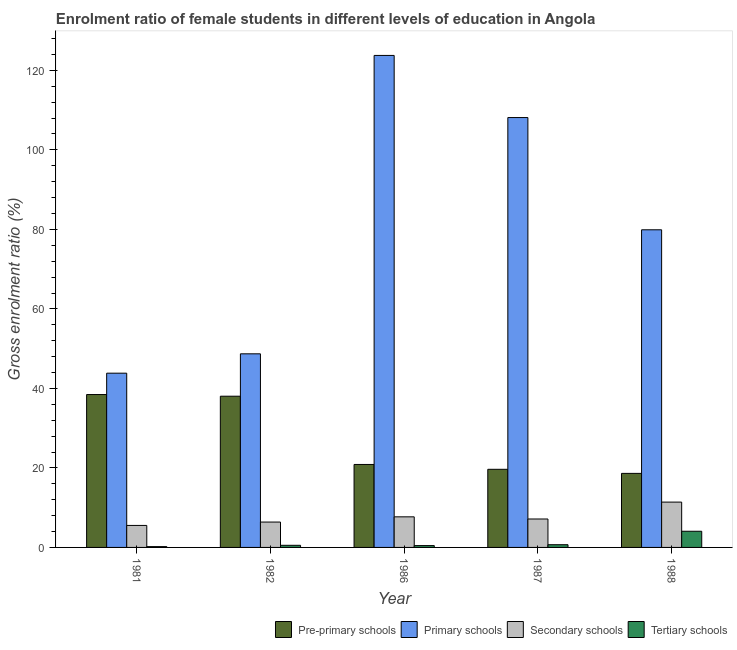How many groups of bars are there?
Ensure brevity in your answer.  5. Are the number of bars per tick equal to the number of legend labels?
Your answer should be compact. Yes. How many bars are there on the 3rd tick from the left?
Your answer should be very brief. 4. What is the label of the 2nd group of bars from the left?
Give a very brief answer. 1982. In how many cases, is the number of bars for a given year not equal to the number of legend labels?
Make the answer very short. 0. What is the gross enrolment ratio(male) in pre-primary schools in 1986?
Your answer should be compact. 20.87. Across all years, what is the maximum gross enrolment ratio(male) in tertiary schools?
Provide a short and direct response. 4.07. Across all years, what is the minimum gross enrolment ratio(male) in pre-primary schools?
Make the answer very short. 18.63. In which year was the gross enrolment ratio(male) in secondary schools maximum?
Your response must be concise. 1988. In which year was the gross enrolment ratio(male) in primary schools minimum?
Provide a succinct answer. 1981. What is the total gross enrolment ratio(male) in tertiary schools in the graph?
Your answer should be compact. 5.95. What is the difference between the gross enrolment ratio(male) in tertiary schools in 1982 and that in 1987?
Ensure brevity in your answer.  -0.15. What is the difference between the gross enrolment ratio(male) in tertiary schools in 1982 and the gross enrolment ratio(male) in pre-primary schools in 1986?
Make the answer very short. 0.07. What is the average gross enrolment ratio(male) in secondary schools per year?
Make the answer very short. 7.63. What is the ratio of the gross enrolment ratio(male) in pre-primary schools in 1982 to that in 1988?
Your answer should be compact. 2.04. What is the difference between the highest and the second highest gross enrolment ratio(male) in pre-primary schools?
Your answer should be very brief. 0.42. What is the difference between the highest and the lowest gross enrolment ratio(male) in tertiary schools?
Make the answer very short. 3.87. In how many years, is the gross enrolment ratio(male) in secondary schools greater than the average gross enrolment ratio(male) in secondary schools taken over all years?
Ensure brevity in your answer.  2. Is the sum of the gross enrolment ratio(male) in primary schools in 1987 and 1988 greater than the maximum gross enrolment ratio(male) in pre-primary schools across all years?
Keep it short and to the point. Yes. What does the 2nd bar from the left in 1981 represents?
Ensure brevity in your answer.  Primary schools. What does the 2nd bar from the right in 1988 represents?
Provide a short and direct response. Secondary schools. Are all the bars in the graph horizontal?
Provide a short and direct response. No. How many years are there in the graph?
Your answer should be very brief. 5. Are the values on the major ticks of Y-axis written in scientific E-notation?
Offer a very short reply. No. Does the graph contain any zero values?
Give a very brief answer. No. Does the graph contain grids?
Offer a terse response. No. Where does the legend appear in the graph?
Provide a succinct answer. Bottom right. How are the legend labels stacked?
Offer a very short reply. Horizontal. What is the title of the graph?
Ensure brevity in your answer.  Enrolment ratio of female students in different levels of education in Angola. Does "Second 20% of population" appear as one of the legend labels in the graph?
Make the answer very short. No. What is the label or title of the X-axis?
Make the answer very short. Year. What is the label or title of the Y-axis?
Your response must be concise. Gross enrolment ratio (%). What is the Gross enrolment ratio (%) of Pre-primary schools in 1981?
Give a very brief answer. 38.46. What is the Gross enrolment ratio (%) of Primary schools in 1981?
Offer a very short reply. 43.83. What is the Gross enrolment ratio (%) in Secondary schools in 1981?
Offer a terse response. 5.53. What is the Gross enrolment ratio (%) in Tertiary schools in 1981?
Your answer should be compact. 0.2. What is the Gross enrolment ratio (%) of Pre-primary schools in 1982?
Offer a terse response. 38.04. What is the Gross enrolment ratio (%) of Primary schools in 1982?
Keep it short and to the point. 48.7. What is the Gross enrolment ratio (%) in Secondary schools in 1982?
Your answer should be compact. 6.38. What is the Gross enrolment ratio (%) of Tertiary schools in 1982?
Your response must be concise. 0.53. What is the Gross enrolment ratio (%) in Pre-primary schools in 1986?
Keep it short and to the point. 20.87. What is the Gross enrolment ratio (%) in Primary schools in 1986?
Provide a succinct answer. 123.76. What is the Gross enrolment ratio (%) of Secondary schools in 1986?
Your response must be concise. 7.7. What is the Gross enrolment ratio (%) of Tertiary schools in 1986?
Give a very brief answer. 0.46. What is the Gross enrolment ratio (%) in Pre-primary schools in 1987?
Offer a terse response. 19.65. What is the Gross enrolment ratio (%) in Primary schools in 1987?
Make the answer very short. 108.13. What is the Gross enrolment ratio (%) in Secondary schools in 1987?
Offer a very short reply. 7.15. What is the Gross enrolment ratio (%) of Tertiary schools in 1987?
Keep it short and to the point. 0.68. What is the Gross enrolment ratio (%) of Pre-primary schools in 1988?
Your answer should be compact. 18.63. What is the Gross enrolment ratio (%) of Primary schools in 1988?
Provide a succinct answer. 79.9. What is the Gross enrolment ratio (%) in Secondary schools in 1988?
Ensure brevity in your answer.  11.4. What is the Gross enrolment ratio (%) of Tertiary schools in 1988?
Give a very brief answer. 4.07. Across all years, what is the maximum Gross enrolment ratio (%) in Pre-primary schools?
Your answer should be very brief. 38.46. Across all years, what is the maximum Gross enrolment ratio (%) of Primary schools?
Offer a terse response. 123.76. Across all years, what is the maximum Gross enrolment ratio (%) of Secondary schools?
Ensure brevity in your answer.  11.4. Across all years, what is the maximum Gross enrolment ratio (%) of Tertiary schools?
Make the answer very short. 4.07. Across all years, what is the minimum Gross enrolment ratio (%) in Pre-primary schools?
Your answer should be very brief. 18.63. Across all years, what is the minimum Gross enrolment ratio (%) in Primary schools?
Offer a very short reply. 43.83. Across all years, what is the minimum Gross enrolment ratio (%) in Secondary schools?
Your response must be concise. 5.53. Across all years, what is the minimum Gross enrolment ratio (%) in Tertiary schools?
Your answer should be very brief. 0.2. What is the total Gross enrolment ratio (%) in Pre-primary schools in the graph?
Give a very brief answer. 135.64. What is the total Gross enrolment ratio (%) in Primary schools in the graph?
Provide a short and direct response. 404.33. What is the total Gross enrolment ratio (%) of Secondary schools in the graph?
Offer a very short reply. 38.16. What is the total Gross enrolment ratio (%) in Tertiary schools in the graph?
Provide a succinct answer. 5.95. What is the difference between the Gross enrolment ratio (%) of Pre-primary schools in 1981 and that in 1982?
Keep it short and to the point. 0.42. What is the difference between the Gross enrolment ratio (%) of Primary schools in 1981 and that in 1982?
Ensure brevity in your answer.  -4.87. What is the difference between the Gross enrolment ratio (%) in Secondary schools in 1981 and that in 1982?
Provide a short and direct response. -0.85. What is the difference between the Gross enrolment ratio (%) of Tertiary schools in 1981 and that in 1982?
Offer a terse response. -0.33. What is the difference between the Gross enrolment ratio (%) of Pre-primary schools in 1981 and that in 1986?
Offer a terse response. 17.59. What is the difference between the Gross enrolment ratio (%) of Primary schools in 1981 and that in 1986?
Your response must be concise. -79.93. What is the difference between the Gross enrolment ratio (%) in Secondary schools in 1981 and that in 1986?
Provide a succinct answer. -2.16. What is the difference between the Gross enrolment ratio (%) in Tertiary schools in 1981 and that in 1986?
Provide a short and direct response. -0.26. What is the difference between the Gross enrolment ratio (%) in Pre-primary schools in 1981 and that in 1987?
Give a very brief answer. 18.81. What is the difference between the Gross enrolment ratio (%) of Primary schools in 1981 and that in 1987?
Your answer should be very brief. -64.3. What is the difference between the Gross enrolment ratio (%) of Secondary schools in 1981 and that in 1987?
Ensure brevity in your answer.  -1.62. What is the difference between the Gross enrolment ratio (%) in Tertiary schools in 1981 and that in 1987?
Offer a very short reply. -0.48. What is the difference between the Gross enrolment ratio (%) in Pre-primary schools in 1981 and that in 1988?
Provide a short and direct response. 19.83. What is the difference between the Gross enrolment ratio (%) in Primary schools in 1981 and that in 1988?
Ensure brevity in your answer.  -36.07. What is the difference between the Gross enrolment ratio (%) of Secondary schools in 1981 and that in 1988?
Your answer should be compact. -5.87. What is the difference between the Gross enrolment ratio (%) in Tertiary schools in 1981 and that in 1988?
Your answer should be compact. -3.87. What is the difference between the Gross enrolment ratio (%) of Pre-primary schools in 1982 and that in 1986?
Offer a terse response. 17.17. What is the difference between the Gross enrolment ratio (%) of Primary schools in 1982 and that in 1986?
Provide a short and direct response. -75.06. What is the difference between the Gross enrolment ratio (%) of Secondary schools in 1982 and that in 1986?
Ensure brevity in your answer.  -1.31. What is the difference between the Gross enrolment ratio (%) in Tertiary schools in 1982 and that in 1986?
Your response must be concise. 0.07. What is the difference between the Gross enrolment ratio (%) in Pre-primary schools in 1982 and that in 1987?
Offer a terse response. 18.39. What is the difference between the Gross enrolment ratio (%) of Primary schools in 1982 and that in 1987?
Provide a succinct answer. -59.43. What is the difference between the Gross enrolment ratio (%) of Secondary schools in 1982 and that in 1987?
Offer a very short reply. -0.77. What is the difference between the Gross enrolment ratio (%) in Tertiary schools in 1982 and that in 1987?
Give a very brief answer. -0.15. What is the difference between the Gross enrolment ratio (%) in Pre-primary schools in 1982 and that in 1988?
Offer a very short reply. 19.41. What is the difference between the Gross enrolment ratio (%) of Primary schools in 1982 and that in 1988?
Ensure brevity in your answer.  -31.2. What is the difference between the Gross enrolment ratio (%) in Secondary schools in 1982 and that in 1988?
Offer a very short reply. -5.02. What is the difference between the Gross enrolment ratio (%) in Tertiary schools in 1982 and that in 1988?
Provide a short and direct response. -3.53. What is the difference between the Gross enrolment ratio (%) in Pre-primary schools in 1986 and that in 1987?
Your response must be concise. 1.22. What is the difference between the Gross enrolment ratio (%) of Primary schools in 1986 and that in 1987?
Offer a terse response. 15.63. What is the difference between the Gross enrolment ratio (%) of Secondary schools in 1986 and that in 1987?
Your answer should be very brief. 0.55. What is the difference between the Gross enrolment ratio (%) of Tertiary schools in 1986 and that in 1987?
Your response must be concise. -0.22. What is the difference between the Gross enrolment ratio (%) of Pre-primary schools in 1986 and that in 1988?
Provide a succinct answer. 2.24. What is the difference between the Gross enrolment ratio (%) of Primary schools in 1986 and that in 1988?
Your response must be concise. 43.86. What is the difference between the Gross enrolment ratio (%) of Secondary schools in 1986 and that in 1988?
Your answer should be very brief. -3.71. What is the difference between the Gross enrolment ratio (%) in Tertiary schools in 1986 and that in 1988?
Your answer should be very brief. -3.61. What is the difference between the Gross enrolment ratio (%) in Pre-primary schools in 1987 and that in 1988?
Your answer should be very brief. 1.02. What is the difference between the Gross enrolment ratio (%) in Primary schools in 1987 and that in 1988?
Give a very brief answer. 28.23. What is the difference between the Gross enrolment ratio (%) in Secondary schools in 1987 and that in 1988?
Provide a short and direct response. -4.25. What is the difference between the Gross enrolment ratio (%) of Tertiary schools in 1987 and that in 1988?
Your response must be concise. -3.38. What is the difference between the Gross enrolment ratio (%) in Pre-primary schools in 1981 and the Gross enrolment ratio (%) in Primary schools in 1982?
Provide a succinct answer. -10.24. What is the difference between the Gross enrolment ratio (%) in Pre-primary schools in 1981 and the Gross enrolment ratio (%) in Secondary schools in 1982?
Your answer should be compact. 32.08. What is the difference between the Gross enrolment ratio (%) in Pre-primary schools in 1981 and the Gross enrolment ratio (%) in Tertiary schools in 1982?
Ensure brevity in your answer.  37.92. What is the difference between the Gross enrolment ratio (%) of Primary schools in 1981 and the Gross enrolment ratio (%) of Secondary schools in 1982?
Keep it short and to the point. 37.45. What is the difference between the Gross enrolment ratio (%) of Primary schools in 1981 and the Gross enrolment ratio (%) of Tertiary schools in 1982?
Your answer should be compact. 43.3. What is the difference between the Gross enrolment ratio (%) of Secondary schools in 1981 and the Gross enrolment ratio (%) of Tertiary schools in 1982?
Provide a short and direct response. 5. What is the difference between the Gross enrolment ratio (%) of Pre-primary schools in 1981 and the Gross enrolment ratio (%) of Primary schools in 1986?
Give a very brief answer. -85.3. What is the difference between the Gross enrolment ratio (%) in Pre-primary schools in 1981 and the Gross enrolment ratio (%) in Secondary schools in 1986?
Keep it short and to the point. 30.76. What is the difference between the Gross enrolment ratio (%) in Pre-primary schools in 1981 and the Gross enrolment ratio (%) in Tertiary schools in 1986?
Your answer should be compact. 38. What is the difference between the Gross enrolment ratio (%) in Primary schools in 1981 and the Gross enrolment ratio (%) in Secondary schools in 1986?
Provide a succinct answer. 36.14. What is the difference between the Gross enrolment ratio (%) of Primary schools in 1981 and the Gross enrolment ratio (%) of Tertiary schools in 1986?
Ensure brevity in your answer.  43.37. What is the difference between the Gross enrolment ratio (%) of Secondary schools in 1981 and the Gross enrolment ratio (%) of Tertiary schools in 1986?
Your answer should be very brief. 5.07. What is the difference between the Gross enrolment ratio (%) in Pre-primary schools in 1981 and the Gross enrolment ratio (%) in Primary schools in 1987?
Give a very brief answer. -69.67. What is the difference between the Gross enrolment ratio (%) of Pre-primary schools in 1981 and the Gross enrolment ratio (%) of Secondary schools in 1987?
Offer a very short reply. 31.31. What is the difference between the Gross enrolment ratio (%) of Pre-primary schools in 1981 and the Gross enrolment ratio (%) of Tertiary schools in 1987?
Your answer should be very brief. 37.77. What is the difference between the Gross enrolment ratio (%) in Primary schools in 1981 and the Gross enrolment ratio (%) in Secondary schools in 1987?
Your response must be concise. 36.68. What is the difference between the Gross enrolment ratio (%) in Primary schools in 1981 and the Gross enrolment ratio (%) in Tertiary schools in 1987?
Ensure brevity in your answer.  43.15. What is the difference between the Gross enrolment ratio (%) in Secondary schools in 1981 and the Gross enrolment ratio (%) in Tertiary schools in 1987?
Make the answer very short. 4.85. What is the difference between the Gross enrolment ratio (%) of Pre-primary schools in 1981 and the Gross enrolment ratio (%) of Primary schools in 1988?
Your answer should be compact. -41.44. What is the difference between the Gross enrolment ratio (%) of Pre-primary schools in 1981 and the Gross enrolment ratio (%) of Secondary schools in 1988?
Give a very brief answer. 27.05. What is the difference between the Gross enrolment ratio (%) in Pre-primary schools in 1981 and the Gross enrolment ratio (%) in Tertiary schools in 1988?
Offer a very short reply. 34.39. What is the difference between the Gross enrolment ratio (%) of Primary schools in 1981 and the Gross enrolment ratio (%) of Secondary schools in 1988?
Keep it short and to the point. 32.43. What is the difference between the Gross enrolment ratio (%) in Primary schools in 1981 and the Gross enrolment ratio (%) in Tertiary schools in 1988?
Keep it short and to the point. 39.76. What is the difference between the Gross enrolment ratio (%) of Secondary schools in 1981 and the Gross enrolment ratio (%) of Tertiary schools in 1988?
Provide a succinct answer. 1.46. What is the difference between the Gross enrolment ratio (%) of Pre-primary schools in 1982 and the Gross enrolment ratio (%) of Primary schools in 1986?
Provide a short and direct response. -85.73. What is the difference between the Gross enrolment ratio (%) of Pre-primary schools in 1982 and the Gross enrolment ratio (%) of Secondary schools in 1986?
Provide a succinct answer. 30.34. What is the difference between the Gross enrolment ratio (%) in Pre-primary schools in 1982 and the Gross enrolment ratio (%) in Tertiary schools in 1986?
Provide a short and direct response. 37.57. What is the difference between the Gross enrolment ratio (%) in Primary schools in 1982 and the Gross enrolment ratio (%) in Secondary schools in 1986?
Offer a very short reply. 41. What is the difference between the Gross enrolment ratio (%) of Primary schools in 1982 and the Gross enrolment ratio (%) of Tertiary schools in 1986?
Provide a short and direct response. 48.24. What is the difference between the Gross enrolment ratio (%) of Secondary schools in 1982 and the Gross enrolment ratio (%) of Tertiary schools in 1986?
Offer a terse response. 5.92. What is the difference between the Gross enrolment ratio (%) of Pre-primary schools in 1982 and the Gross enrolment ratio (%) of Primary schools in 1987?
Your answer should be compact. -70.1. What is the difference between the Gross enrolment ratio (%) in Pre-primary schools in 1982 and the Gross enrolment ratio (%) in Secondary schools in 1987?
Your answer should be very brief. 30.89. What is the difference between the Gross enrolment ratio (%) of Pre-primary schools in 1982 and the Gross enrolment ratio (%) of Tertiary schools in 1987?
Offer a very short reply. 37.35. What is the difference between the Gross enrolment ratio (%) in Primary schools in 1982 and the Gross enrolment ratio (%) in Secondary schools in 1987?
Your response must be concise. 41.55. What is the difference between the Gross enrolment ratio (%) in Primary schools in 1982 and the Gross enrolment ratio (%) in Tertiary schools in 1987?
Give a very brief answer. 48.02. What is the difference between the Gross enrolment ratio (%) in Secondary schools in 1982 and the Gross enrolment ratio (%) in Tertiary schools in 1987?
Your response must be concise. 5.7. What is the difference between the Gross enrolment ratio (%) of Pre-primary schools in 1982 and the Gross enrolment ratio (%) of Primary schools in 1988?
Provide a short and direct response. -41.86. What is the difference between the Gross enrolment ratio (%) of Pre-primary schools in 1982 and the Gross enrolment ratio (%) of Secondary schools in 1988?
Your answer should be very brief. 26.63. What is the difference between the Gross enrolment ratio (%) in Pre-primary schools in 1982 and the Gross enrolment ratio (%) in Tertiary schools in 1988?
Your response must be concise. 33.97. What is the difference between the Gross enrolment ratio (%) of Primary schools in 1982 and the Gross enrolment ratio (%) of Secondary schools in 1988?
Ensure brevity in your answer.  37.3. What is the difference between the Gross enrolment ratio (%) in Primary schools in 1982 and the Gross enrolment ratio (%) in Tertiary schools in 1988?
Provide a succinct answer. 44.63. What is the difference between the Gross enrolment ratio (%) in Secondary schools in 1982 and the Gross enrolment ratio (%) in Tertiary schools in 1988?
Provide a short and direct response. 2.31. What is the difference between the Gross enrolment ratio (%) of Pre-primary schools in 1986 and the Gross enrolment ratio (%) of Primary schools in 1987?
Offer a terse response. -87.26. What is the difference between the Gross enrolment ratio (%) of Pre-primary schools in 1986 and the Gross enrolment ratio (%) of Secondary schools in 1987?
Ensure brevity in your answer.  13.72. What is the difference between the Gross enrolment ratio (%) in Pre-primary schools in 1986 and the Gross enrolment ratio (%) in Tertiary schools in 1987?
Provide a succinct answer. 20.19. What is the difference between the Gross enrolment ratio (%) in Primary schools in 1986 and the Gross enrolment ratio (%) in Secondary schools in 1987?
Provide a short and direct response. 116.61. What is the difference between the Gross enrolment ratio (%) in Primary schools in 1986 and the Gross enrolment ratio (%) in Tertiary schools in 1987?
Make the answer very short. 123.08. What is the difference between the Gross enrolment ratio (%) in Secondary schools in 1986 and the Gross enrolment ratio (%) in Tertiary schools in 1987?
Offer a very short reply. 7.01. What is the difference between the Gross enrolment ratio (%) of Pre-primary schools in 1986 and the Gross enrolment ratio (%) of Primary schools in 1988?
Offer a terse response. -59.03. What is the difference between the Gross enrolment ratio (%) of Pre-primary schools in 1986 and the Gross enrolment ratio (%) of Secondary schools in 1988?
Your answer should be very brief. 9.47. What is the difference between the Gross enrolment ratio (%) of Pre-primary schools in 1986 and the Gross enrolment ratio (%) of Tertiary schools in 1988?
Your response must be concise. 16.8. What is the difference between the Gross enrolment ratio (%) of Primary schools in 1986 and the Gross enrolment ratio (%) of Secondary schools in 1988?
Provide a short and direct response. 112.36. What is the difference between the Gross enrolment ratio (%) in Primary schools in 1986 and the Gross enrolment ratio (%) in Tertiary schools in 1988?
Ensure brevity in your answer.  119.69. What is the difference between the Gross enrolment ratio (%) of Secondary schools in 1986 and the Gross enrolment ratio (%) of Tertiary schools in 1988?
Provide a short and direct response. 3.63. What is the difference between the Gross enrolment ratio (%) of Pre-primary schools in 1987 and the Gross enrolment ratio (%) of Primary schools in 1988?
Your answer should be compact. -60.25. What is the difference between the Gross enrolment ratio (%) of Pre-primary schools in 1987 and the Gross enrolment ratio (%) of Secondary schools in 1988?
Your answer should be very brief. 8.25. What is the difference between the Gross enrolment ratio (%) in Pre-primary schools in 1987 and the Gross enrolment ratio (%) in Tertiary schools in 1988?
Your answer should be compact. 15.58. What is the difference between the Gross enrolment ratio (%) of Primary schools in 1987 and the Gross enrolment ratio (%) of Secondary schools in 1988?
Provide a short and direct response. 96.73. What is the difference between the Gross enrolment ratio (%) in Primary schools in 1987 and the Gross enrolment ratio (%) in Tertiary schools in 1988?
Your answer should be very brief. 104.06. What is the difference between the Gross enrolment ratio (%) of Secondary schools in 1987 and the Gross enrolment ratio (%) of Tertiary schools in 1988?
Give a very brief answer. 3.08. What is the average Gross enrolment ratio (%) of Pre-primary schools per year?
Your answer should be very brief. 27.13. What is the average Gross enrolment ratio (%) in Primary schools per year?
Keep it short and to the point. 80.87. What is the average Gross enrolment ratio (%) in Secondary schools per year?
Offer a terse response. 7.63. What is the average Gross enrolment ratio (%) in Tertiary schools per year?
Your answer should be compact. 1.19. In the year 1981, what is the difference between the Gross enrolment ratio (%) of Pre-primary schools and Gross enrolment ratio (%) of Primary schools?
Your answer should be very brief. -5.37. In the year 1981, what is the difference between the Gross enrolment ratio (%) of Pre-primary schools and Gross enrolment ratio (%) of Secondary schools?
Provide a succinct answer. 32.93. In the year 1981, what is the difference between the Gross enrolment ratio (%) of Pre-primary schools and Gross enrolment ratio (%) of Tertiary schools?
Ensure brevity in your answer.  38.26. In the year 1981, what is the difference between the Gross enrolment ratio (%) in Primary schools and Gross enrolment ratio (%) in Secondary schools?
Offer a very short reply. 38.3. In the year 1981, what is the difference between the Gross enrolment ratio (%) of Primary schools and Gross enrolment ratio (%) of Tertiary schools?
Your answer should be very brief. 43.63. In the year 1981, what is the difference between the Gross enrolment ratio (%) of Secondary schools and Gross enrolment ratio (%) of Tertiary schools?
Your answer should be very brief. 5.33. In the year 1982, what is the difference between the Gross enrolment ratio (%) of Pre-primary schools and Gross enrolment ratio (%) of Primary schools?
Keep it short and to the point. -10.66. In the year 1982, what is the difference between the Gross enrolment ratio (%) of Pre-primary schools and Gross enrolment ratio (%) of Secondary schools?
Provide a short and direct response. 31.66. In the year 1982, what is the difference between the Gross enrolment ratio (%) in Pre-primary schools and Gross enrolment ratio (%) in Tertiary schools?
Offer a very short reply. 37.5. In the year 1982, what is the difference between the Gross enrolment ratio (%) of Primary schools and Gross enrolment ratio (%) of Secondary schools?
Offer a very short reply. 42.32. In the year 1982, what is the difference between the Gross enrolment ratio (%) in Primary schools and Gross enrolment ratio (%) in Tertiary schools?
Offer a terse response. 48.17. In the year 1982, what is the difference between the Gross enrolment ratio (%) of Secondary schools and Gross enrolment ratio (%) of Tertiary schools?
Keep it short and to the point. 5.85. In the year 1986, what is the difference between the Gross enrolment ratio (%) of Pre-primary schools and Gross enrolment ratio (%) of Primary schools?
Make the answer very short. -102.89. In the year 1986, what is the difference between the Gross enrolment ratio (%) of Pre-primary schools and Gross enrolment ratio (%) of Secondary schools?
Ensure brevity in your answer.  13.17. In the year 1986, what is the difference between the Gross enrolment ratio (%) of Pre-primary schools and Gross enrolment ratio (%) of Tertiary schools?
Offer a very short reply. 20.41. In the year 1986, what is the difference between the Gross enrolment ratio (%) in Primary schools and Gross enrolment ratio (%) in Secondary schools?
Your answer should be compact. 116.07. In the year 1986, what is the difference between the Gross enrolment ratio (%) of Primary schools and Gross enrolment ratio (%) of Tertiary schools?
Give a very brief answer. 123.3. In the year 1986, what is the difference between the Gross enrolment ratio (%) of Secondary schools and Gross enrolment ratio (%) of Tertiary schools?
Your response must be concise. 7.23. In the year 1987, what is the difference between the Gross enrolment ratio (%) in Pre-primary schools and Gross enrolment ratio (%) in Primary schools?
Give a very brief answer. -88.48. In the year 1987, what is the difference between the Gross enrolment ratio (%) in Pre-primary schools and Gross enrolment ratio (%) in Secondary schools?
Your answer should be very brief. 12.5. In the year 1987, what is the difference between the Gross enrolment ratio (%) of Pre-primary schools and Gross enrolment ratio (%) of Tertiary schools?
Keep it short and to the point. 18.97. In the year 1987, what is the difference between the Gross enrolment ratio (%) in Primary schools and Gross enrolment ratio (%) in Secondary schools?
Provide a succinct answer. 100.98. In the year 1987, what is the difference between the Gross enrolment ratio (%) of Primary schools and Gross enrolment ratio (%) of Tertiary schools?
Offer a very short reply. 107.45. In the year 1987, what is the difference between the Gross enrolment ratio (%) in Secondary schools and Gross enrolment ratio (%) in Tertiary schools?
Offer a very short reply. 6.47. In the year 1988, what is the difference between the Gross enrolment ratio (%) in Pre-primary schools and Gross enrolment ratio (%) in Primary schools?
Give a very brief answer. -61.28. In the year 1988, what is the difference between the Gross enrolment ratio (%) in Pre-primary schools and Gross enrolment ratio (%) in Secondary schools?
Provide a succinct answer. 7.22. In the year 1988, what is the difference between the Gross enrolment ratio (%) of Pre-primary schools and Gross enrolment ratio (%) of Tertiary schools?
Your answer should be very brief. 14.56. In the year 1988, what is the difference between the Gross enrolment ratio (%) of Primary schools and Gross enrolment ratio (%) of Secondary schools?
Ensure brevity in your answer.  68.5. In the year 1988, what is the difference between the Gross enrolment ratio (%) of Primary schools and Gross enrolment ratio (%) of Tertiary schools?
Offer a very short reply. 75.83. In the year 1988, what is the difference between the Gross enrolment ratio (%) of Secondary schools and Gross enrolment ratio (%) of Tertiary schools?
Keep it short and to the point. 7.33. What is the ratio of the Gross enrolment ratio (%) of Pre-primary schools in 1981 to that in 1982?
Offer a very short reply. 1.01. What is the ratio of the Gross enrolment ratio (%) in Primary schools in 1981 to that in 1982?
Your answer should be very brief. 0.9. What is the ratio of the Gross enrolment ratio (%) in Secondary schools in 1981 to that in 1982?
Give a very brief answer. 0.87. What is the ratio of the Gross enrolment ratio (%) of Tertiary schools in 1981 to that in 1982?
Provide a short and direct response. 0.38. What is the ratio of the Gross enrolment ratio (%) in Pre-primary schools in 1981 to that in 1986?
Your answer should be compact. 1.84. What is the ratio of the Gross enrolment ratio (%) in Primary schools in 1981 to that in 1986?
Give a very brief answer. 0.35. What is the ratio of the Gross enrolment ratio (%) in Secondary schools in 1981 to that in 1986?
Offer a terse response. 0.72. What is the ratio of the Gross enrolment ratio (%) of Tertiary schools in 1981 to that in 1986?
Give a very brief answer. 0.44. What is the ratio of the Gross enrolment ratio (%) of Pre-primary schools in 1981 to that in 1987?
Keep it short and to the point. 1.96. What is the ratio of the Gross enrolment ratio (%) in Primary schools in 1981 to that in 1987?
Offer a terse response. 0.41. What is the ratio of the Gross enrolment ratio (%) in Secondary schools in 1981 to that in 1987?
Offer a very short reply. 0.77. What is the ratio of the Gross enrolment ratio (%) in Tertiary schools in 1981 to that in 1987?
Make the answer very short. 0.3. What is the ratio of the Gross enrolment ratio (%) in Pre-primary schools in 1981 to that in 1988?
Your answer should be very brief. 2.06. What is the ratio of the Gross enrolment ratio (%) in Primary schools in 1981 to that in 1988?
Provide a short and direct response. 0.55. What is the ratio of the Gross enrolment ratio (%) in Secondary schools in 1981 to that in 1988?
Give a very brief answer. 0.49. What is the ratio of the Gross enrolment ratio (%) in Tertiary schools in 1981 to that in 1988?
Your answer should be very brief. 0.05. What is the ratio of the Gross enrolment ratio (%) in Pre-primary schools in 1982 to that in 1986?
Your response must be concise. 1.82. What is the ratio of the Gross enrolment ratio (%) of Primary schools in 1982 to that in 1986?
Give a very brief answer. 0.39. What is the ratio of the Gross enrolment ratio (%) in Secondary schools in 1982 to that in 1986?
Offer a terse response. 0.83. What is the ratio of the Gross enrolment ratio (%) in Tertiary schools in 1982 to that in 1986?
Give a very brief answer. 1.16. What is the ratio of the Gross enrolment ratio (%) of Pre-primary schools in 1982 to that in 1987?
Give a very brief answer. 1.94. What is the ratio of the Gross enrolment ratio (%) in Primary schools in 1982 to that in 1987?
Keep it short and to the point. 0.45. What is the ratio of the Gross enrolment ratio (%) in Secondary schools in 1982 to that in 1987?
Give a very brief answer. 0.89. What is the ratio of the Gross enrolment ratio (%) in Tertiary schools in 1982 to that in 1987?
Provide a succinct answer. 0.78. What is the ratio of the Gross enrolment ratio (%) of Pre-primary schools in 1982 to that in 1988?
Your response must be concise. 2.04. What is the ratio of the Gross enrolment ratio (%) in Primary schools in 1982 to that in 1988?
Your response must be concise. 0.61. What is the ratio of the Gross enrolment ratio (%) in Secondary schools in 1982 to that in 1988?
Your answer should be compact. 0.56. What is the ratio of the Gross enrolment ratio (%) of Tertiary schools in 1982 to that in 1988?
Your answer should be compact. 0.13. What is the ratio of the Gross enrolment ratio (%) of Pre-primary schools in 1986 to that in 1987?
Your answer should be compact. 1.06. What is the ratio of the Gross enrolment ratio (%) of Primary schools in 1986 to that in 1987?
Make the answer very short. 1.14. What is the ratio of the Gross enrolment ratio (%) in Secondary schools in 1986 to that in 1987?
Provide a succinct answer. 1.08. What is the ratio of the Gross enrolment ratio (%) in Tertiary schools in 1986 to that in 1987?
Offer a terse response. 0.68. What is the ratio of the Gross enrolment ratio (%) in Pre-primary schools in 1986 to that in 1988?
Your answer should be very brief. 1.12. What is the ratio of the Gross enrolment ratio (%) of Primary schools in 1986 to that in 1988?
Provide a short and direct response. 1.55. What is the ratio of the Gross enrolment ratio (%) of Secondary schools in 1986 to that in 1988?
Offer a very short reply. 0.67. What is the ratio of the Gross enrolment ratio (%) of Tertiary schools in 1986 to that in 1988?
Ensure brevity in your answer.  0.11. What is the ratio of the Gross enrolment ratio (%) in Pre-primary schools in 1987 to that in 1988?
Your answer should be compact. 1.05. What is the ratio of the Gross enrolment ratio (%) of Primary schools in 1987 to that in 1988?
Offer a very short reply. 1.35. What is the ratio of the Gross enrolment ratio (%) in Secondary schools in 1987 to that in 1988?
Keep it short and to the point. 0.63. What is the ratio of the Gross enrolment ratio (%) in Tertiary schools in 1987 to that in 1988?
Offer a terse response. 0.17. What is the difference between the highest and the second highest Gross enrolment ratio (%) of Pre-primary schools?
Ensure brevity in your answer.  0.42. What is the difference between the highest and the second highest Gross enrolment ratio (%) of Primary schools?
Ensure brevity in your answer.  15.63. What is the difference between the highest and the second highest Gross enrolment ratio (%) in Secondary schools?
Keep it short and to the point. 3.71. What is the difference between the highest and the second highest Gross enrolment ratio (%) of Tertiary schools?
Your answer should be compact. 3.38. What is the difference between the highest and the lowest Gross enrolment ratio (%) in Pre-primary schools?
Make the answer very short. 19.83. What is the difference between the highest and the lowest Gross enrolment ratio (%) in Primary schools?
Offer a terse response. 79.93. What is the difference between the highest and the lowest Gross enrolment ratio (%) in Secondary schools?
Your answer should be compact. 5.87. What is the difference between the highest and the lowest Gross enrolment ratio (%) of Tertiary schools?
Keep it short and to the point. 3.87. 